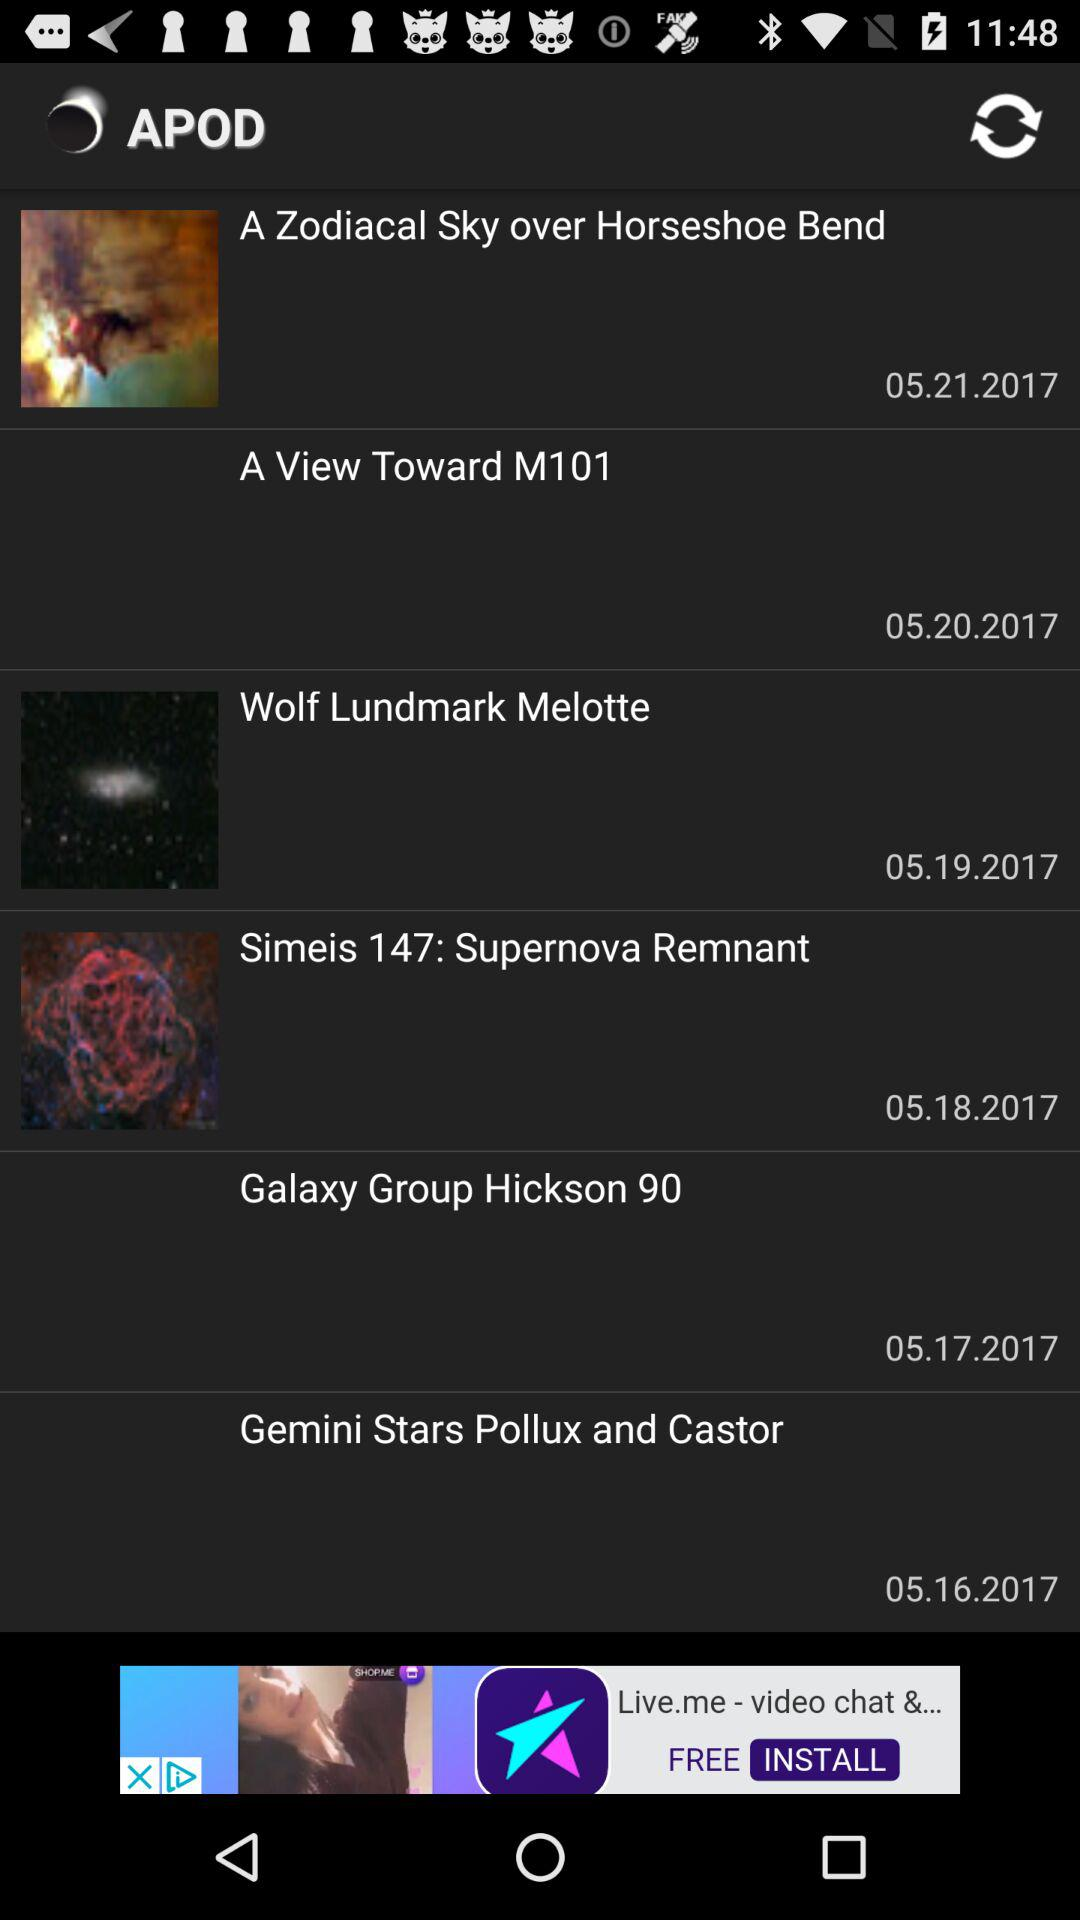What is the featured date of "Galaxy Group Hickson 90"? The featured date of "Galaxy Group Hickson 90" is May 17, 2017. 